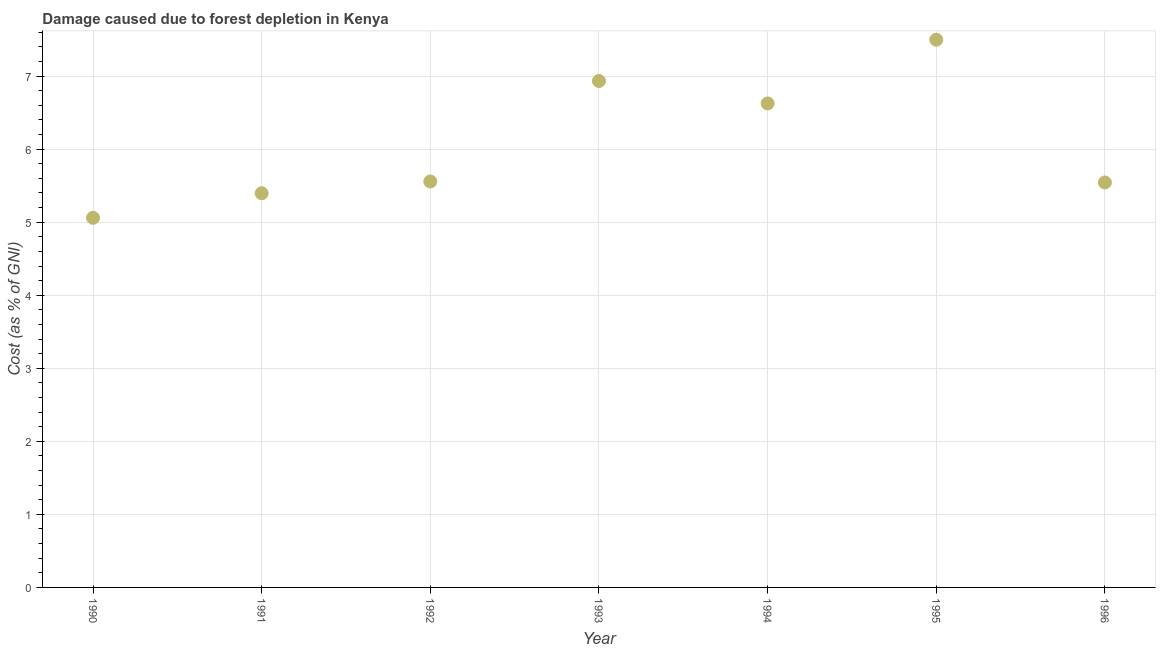What is the damage caused due to forest depletion in 1990?
Make the answer very short. 5.06. Across all years, what is the maximum damage caused due to forest depletion?
Your answer should be very brief. 7.5. Across all years, what is the minimum damage caused due to forest depletion?
Offer a terse response. 5.06. What is the sum of the damage caused due to forest depletion?
Keep it short and to the point. 42.61. What is the difference between the damage caused due to forest depletion in 1990 and 1994?
Offer a terse response. -1.57. What is the average damage caused due to forest depletion per year?
Your answer should be compact. 6.09. What is the median damage caused due to forest depletion?
Offer a very short reply. 5.56. What is the ratio of the damage caused due to forest depletion in 1993 to that in 1996?
Provide a short and direct response. 1.25. Is the damage caused due to forest depletion in 1990 less than that in 1994?
Offer a very short reply. Yes. Is the difference between the damage caused due to forest depletion in 1991 and 1992 greater than the difference between any two years?
Ensure brevity in your answer.  No. What is the difference between the highest and the second highest damage caused due to forest depletion?
Provide a succinct answer. 0.56. What is the difference between the highest and the lowest damage caused due to forest depletion?
Your answer should be very brief. 2.44. Does the damage caused due to forest depletion monotonically increase over the years?
Your answer should be compact. No. What is the title of the graph?
Offer a terse response. Damage caused due to forest depletion in Kenya. What is the label or title of the X-axis?
Provide a succinct answer. Year. What is the label or title of the Y-axis?
Ensure brevity in your answer.  Cost (as % of GNI). What is the Cost (as % of GNI) in 1990?
Offer a very short reply. 5.06. What is the Cost (as % of GNI) in 1991?
Offer a very short reply. 5.4. What is the Cost (as % of GNI) in 1992?
Provide a succinct answer. 5.56. What is the Cost (as % of GNI) in 1993?
Your answer should be very brief. 6.93. What is the Cost (as % of GNI) in 1994?
Give a very brief answer. 6.63. What is the Cost (as % of GNI) in 1995?
Offer a terse response. 7.5. What is the Cost (as % of GNI) in 1996?
Give a very brief answer. 5.54. What is the difference between the Cost (as % of GNI) in 1990 and 1991?
Offer a very short reply. -0.34. What is the difference between the Cost (as % of GNI) in 1990 and 1992?
Provide a succinct answer. -0.5. What is the difference between the Cost (as % of GNI) in 1990 and 1993?
Ensure brevity in your answer.  -1.87. What is the difference between the Cost (as % of GNI) in 1990 and 1994?
Provide a short and direct response. -1.57. What is the difference between the Cost (as % of GNI) in 1990 and 1995?
Your response must be concise. -2.44. What is the difference between the Cost (as % of GNI) in 1990 and 1996?
Keep it short and to the point. -0.48. What is the difference between the Cost (as % of GNI) in 1991 and 1992?
Ensure brevity in your answer.  -0.16. What is the difference between the Cost (as % of GNI) in 1991 and 1993?
Your answer should be very brief. -1.54. What is the difference between the Cost (as % of GNI) in 1991 and 1994?
Give a very brief answer. -1.23. What is the difference between the Cost (as % of GNI) in 1991 and 1995?
Make the answer very short. -2.1. What is the difference between the Cost (as % of GNI) in 1991 and 1996?
Your response must be concise. -0.15. What is the difference between the Cost (as % of GNI) in 1992 and 1993?
Offer a very short reply. -1.38. What is the difference between the Cost (as % of GNI) in 1992 and 1994?
Keep it short and to the point. -1.07. What is the difference between the Cost (as % of GNI) in 1992 and 1995?
Offer a terse response. -1.94. What is the difference between the Cost (as % of GNI) in 1992 and 1996?
Your response must be concise. 0.01. What is the difference between the Cost (as % of GNI) in 1993 and 1994?
Offer a terse response. 0.31. What is the difference between the Cost (as % of GNI) in 1993 and 1995?
Your response must be concise. -0.56. What is the difference between the Cost (as % of GNI) in 1993 and 1996?
Provide a succinct answer. 1.39. What is the difference between the Cost (as % of GNI) in 1994 and 1995?
Keep it short and to the point. -0.87. What is the difference between the Cost (as % of GNI) in 1994 and 1996?
Provide a succinct answer. 1.08. What is the difference between the Cost (as % of GNI) in 1995 and 1996?
Offer a terse response. 1.95. What is the ratio of the Cost (as % of GNI) in 1990 to that in 1991?
Provide a short and direct response. 0.94. What is the ratio of the Cost (as % of GNI) in 1990 to that in 1992?
Provide a short and direct response. 0.91. What is the ratio of the Cost (as % of GNI) in 1990 to that in 1993?
Your answer should be compact. 0.73. What is the ratio of the Cost (as % of GNI) in 1990 to that in 1994?
Provide a succinct answer. 0.76. What is the ratio of the Cost (as % of GNI) in 1990 to that in 1995?
Offer a terse response. 0.68. What is the ratio of the Cost (as % of GNI) in 1991 to that in 1992?
Ensure brevity in your answer.  0.97. What is the ratio of the Cost (as % of GNI) in 1991 to that in 1993?
Offer a terse response. 0.78. What is the ratio of the Cost (as % of GNI) in 1991 to that in 1994?
Offer a very short reply. 0.81. What is the ratio of the Cost (as % of GNI) in 1991 to that in 1995?
Give a very brief answer. 0.72. What is the ratio of the Cost (as % of GNI) in 1991 to that in 1996?
Ensure brevity in your answer.  0.97. What is the ratio of the Cost (as % of GNI) in 1992 to that in 1993?
Keep it short and to the point. 0.8. What is the ratio of the Cost (as % of GNI) in 1992 to that in 1994?
Your answer should be very brief. 0.84. What is the ratio of the Cost (as % of GNI) in 1992 to that in 1995?
Make the answer very short. 0.74. What is the ratio of the Cost (as % of GNI) in 1992 to that in 1996?
Ensure brevity in your answer.  1. What is the ratio of the Cost (as % of GNI) in 1993 to that in 1994?
Give a very brief answer. 1.05. What is the ratio of the Cost (as % of GNI) in 1993 to that in 1995?
Your answer should be very brief. 0.93. What is the ratio of the Cost (as % of GNI) in 1993 to that in 1996?
Provide a succinct answer. 1.25. What is the ratio of the Cost (as % of GNI) in 1994 to that in 1995?
Make the answer very short. 0.88. What is the ratio of the Cost (as % of GNI) in 1994 to that in 1996?
Keep it short and to the point. 1.2. What is the ratio of the Cost (as % of GNI) in 1995 to that in 1996?
Your response must be concise. 1.35. 